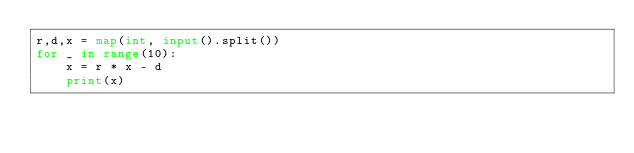<code> <loc_0><loc_0><loc_500><loc_500><_Python_>r,d,x = map(int, input().split())
for _ in range(10):
	x = r * x - d
	print(x)</code> 